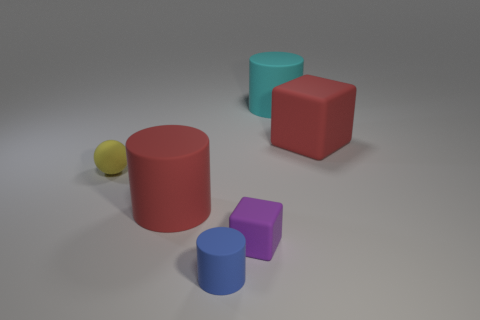Add 2 big cyan things. How many objects exist? 8 Subtract all blocks. How many objects are left? 4 Subtract all rubber cylinders. Subtract all tiny blue cylinders. How many objects are left? 2 Add 1 big cylinders. How many big cylinders are left? 3 Add 1 big cyan matte things. How many big cyan matte things exist? 2 Subtract 0 gray cylinders. How many objects are left? 6 